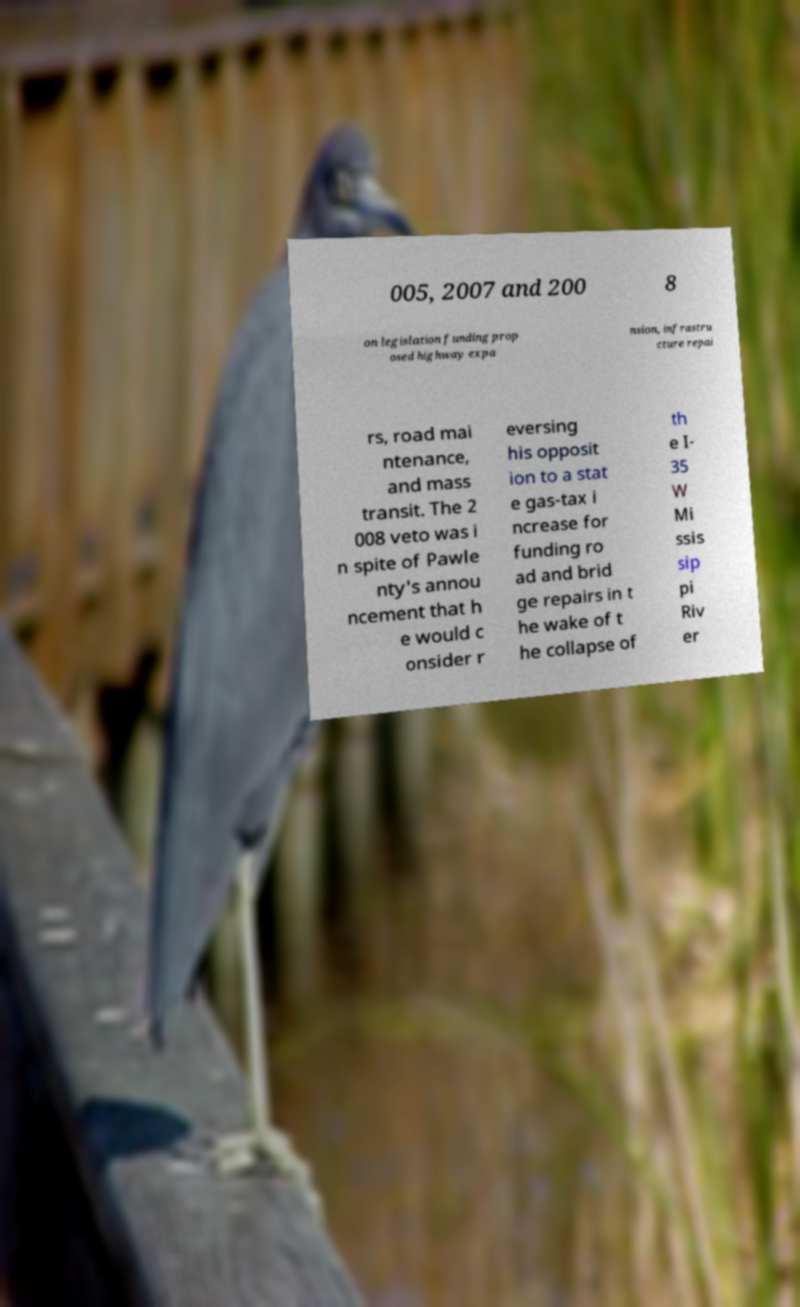Please read and relay the text visible in this image. What does it say? 005, 2007 and 200 8 on legislation funding prop osed highway expa nsion, infrastru cture repai rs, road mai ntenance, and mass transit. The 2 008 veto was i n spite of Pawle nty's annou ncement that h e would c onsider r eversing his opposit ion to a stat e gas-tax i ncrease for funding ro ad and brid ge repairs in t he wake of t he collapse of th e I- 35 W Mi ssis sip pi Riv er 